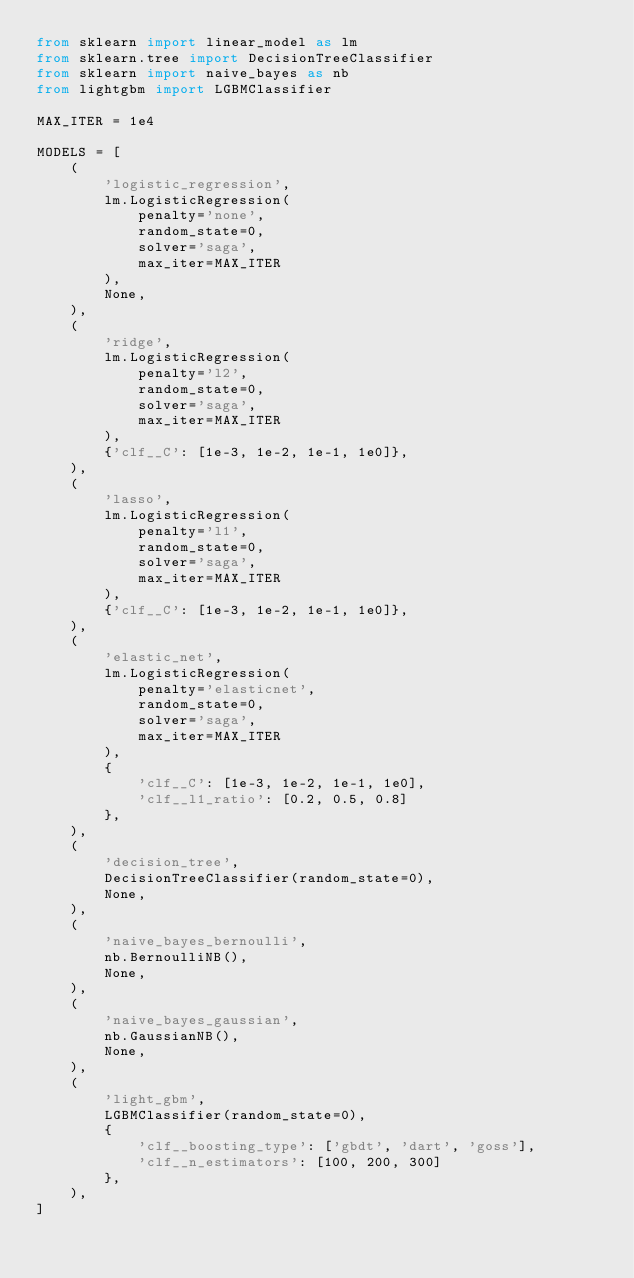Convert code to text. <code><loc_0><loc_0><loc_500><loc_500><_Python_>from sklearn import linear_model as lm
from sklearn.tree import DecisionTreeClassifier
from sklearn import naive_bayes as nb
from lightgbm import LGBMClassifier

MAX_ITER = 1e4

MODELS = [
    (
        'logistic_regression',
        lm.LogisticRegression(
            penalty='none',
            random_state=0,
            solver='saga',
            max_iter=MAX_ITER
        ),
        None,
    ),
    (
        'ridge',
        lm.LogisticRegression(
            penalty='l2',
            random_state=0,
            solver='saga',
            max_iter=MAX_ITER
        ),
        {'clf__C': [1e-3, 1e-2, 1e-1, 1e0]},
    ),
    (
        'lasso',
        lm.LogisticRegression(
            penalty='l1',
            random_state=0,
            solver='saga',
            max_iter=MAX_ITER
        ),
        {'clf__C': [1e-3, 1e-2, 1e-1, 1e0]},
    ),
    (
        'elastic_net',
        lm.LogisticRegression(
            penalty='elasticnet',
            random_state=0,
            solver='saga',
            max_iter=MAX_ITER
        ),
        {
            'clf__C': [1e-3, 1e-2, 1e-1, 1e0],
            'clf__l1_ratio': [0.2, 0.5, 0.8]
        },
    ),
    (
        'decision_tree',
        DecisionTreeClassifier(random_state=0),
        None,
    ),
    (
        'naive_bayes_bernoulli',
        nb.BernoulliNB(),
        None,
    ),
    (
        'naive_bayes_gaussian',
        nb.GaussianNB(),
        None,
    ),
    (
        'light_gbm',
        LGBMClassifier(random_state=0),
        {
            'clf__boosting_type': ['gbdt', 'dart', 'goss'],
            'clf__n_estimators': [100, 200, 300]
        },
    ),
]</code> 